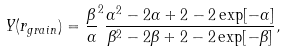<formula> <loc_0><loc_0><loc_500><loc_500>Y ( r _ { g r a i n } ) = \frac { \beta } { \alpha } ^ { 2 } \frac { \alpha ^ { 2 } - 2 \alpha + 2 - 2 \exp [ - \alpha ] } { \beta ^ { 2 } - 2 \beta + 2 - 2 \exp [ - \beta ] } ,</formula> 